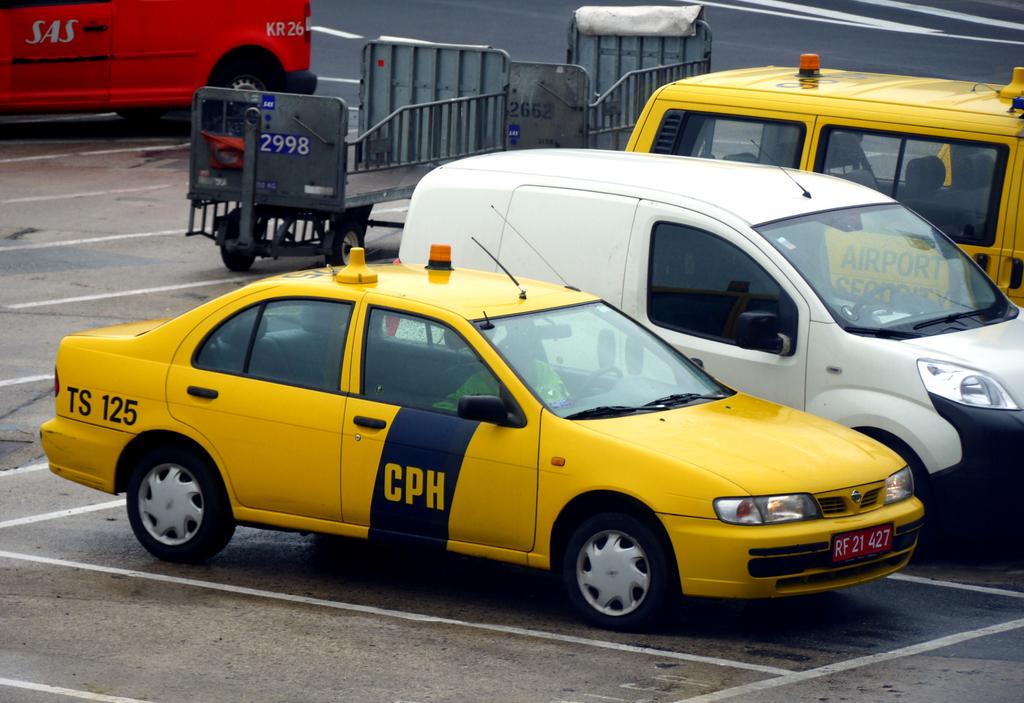Is that a taxi cab?
Offer a terse response. Unanswerable. What is before the numbers 125?
Offer a very short reply. Ts. 